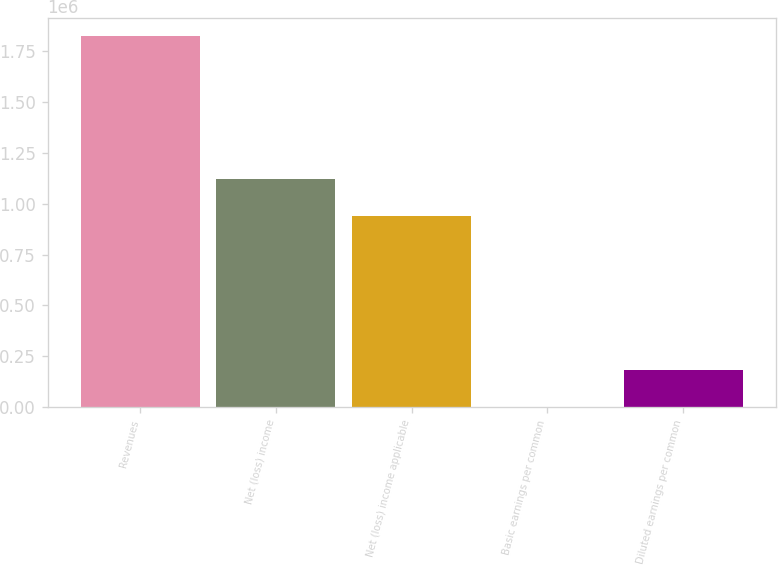<chart> <loc_0><loc_0><loc_500><loc_500><bar_chart><fcel>Revenues<fcel>Net (loss) income<fcel>Net (loss) income applicable<fcel>Basic earnings per common<fcel>Diluted earnings per common<nl><fcel>1.82459e+06<fcel>1.12085e+06<fcel>938387<fcel>2.04<fcel>182461<nl></chart> 